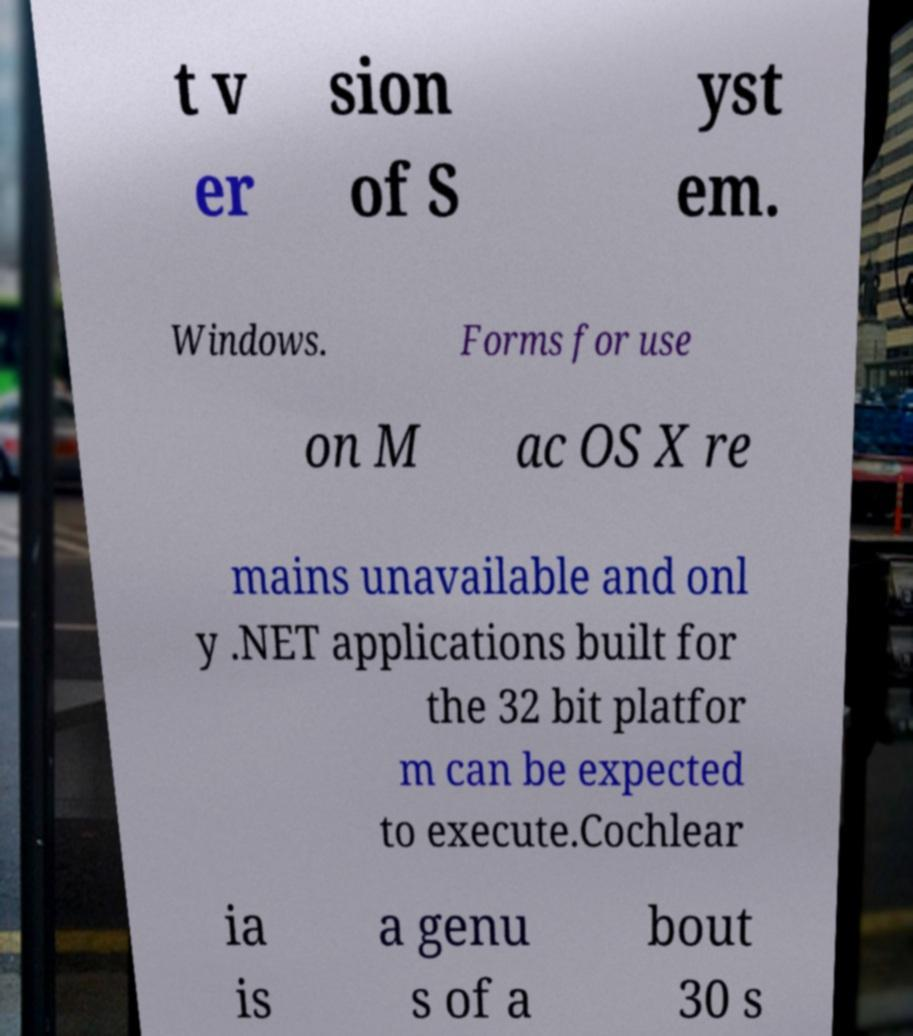Please identify and transcribe the text found in this image. t v er sion of S yst em. Windows. Forms for use on M ac OS X re mains unavailable and onl y .NET applications built for the 32 bit platfor m can be expected to execute.Cochlear ia is a genu s of a bout 30 s 